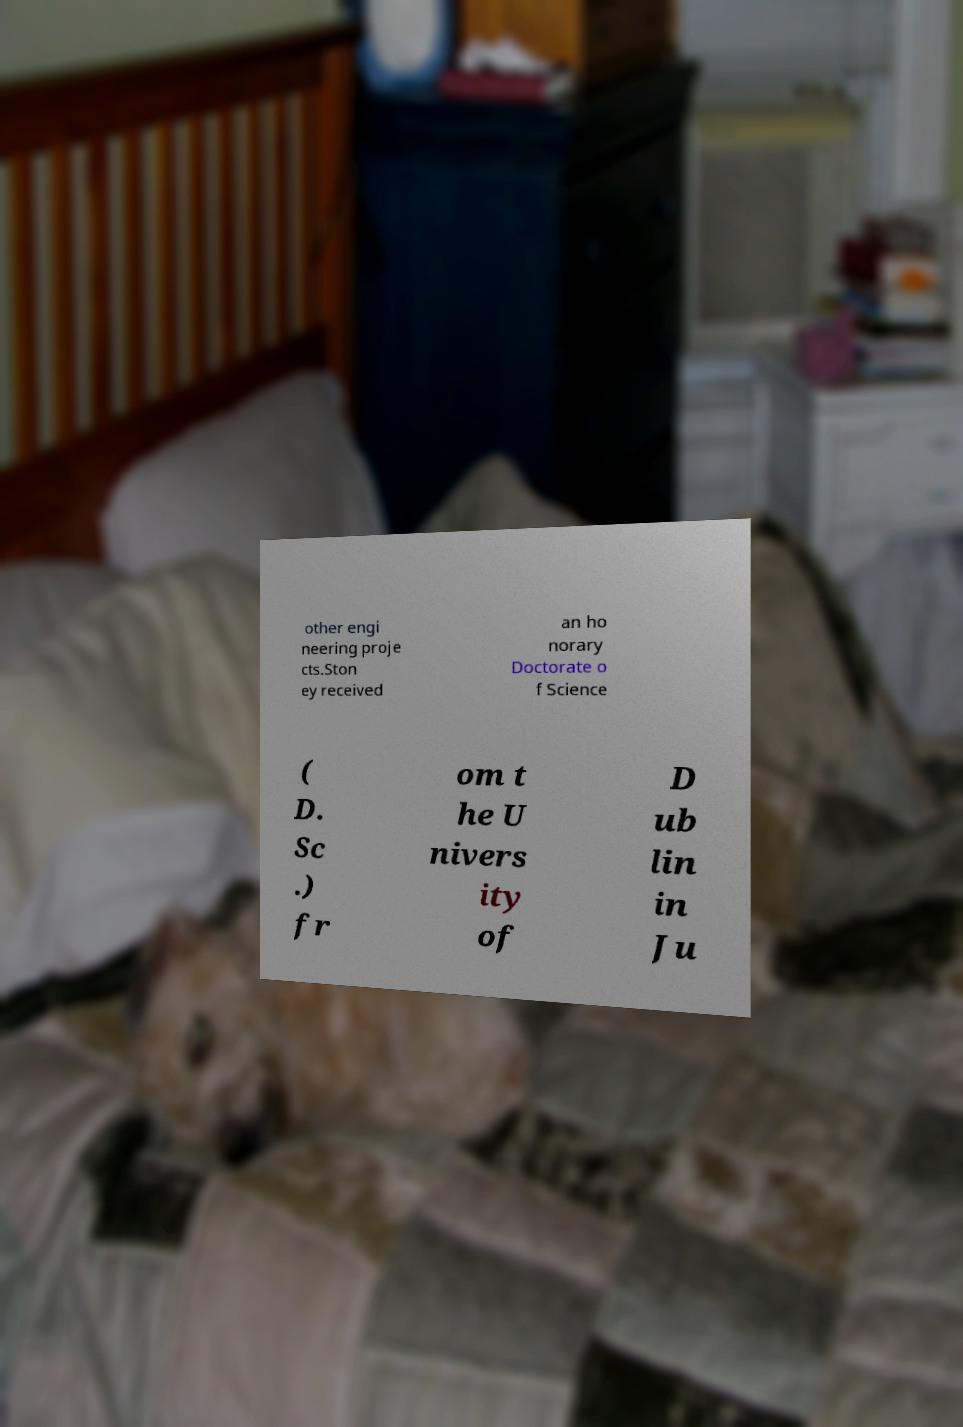I need the written content from this picture converted into text. Can you do that? other engi neering proje cts.Ston ey received an ho norary Doctorate o f Science ( D. Sc .) fr om t he U nivers ity of D ub lin in Ju 